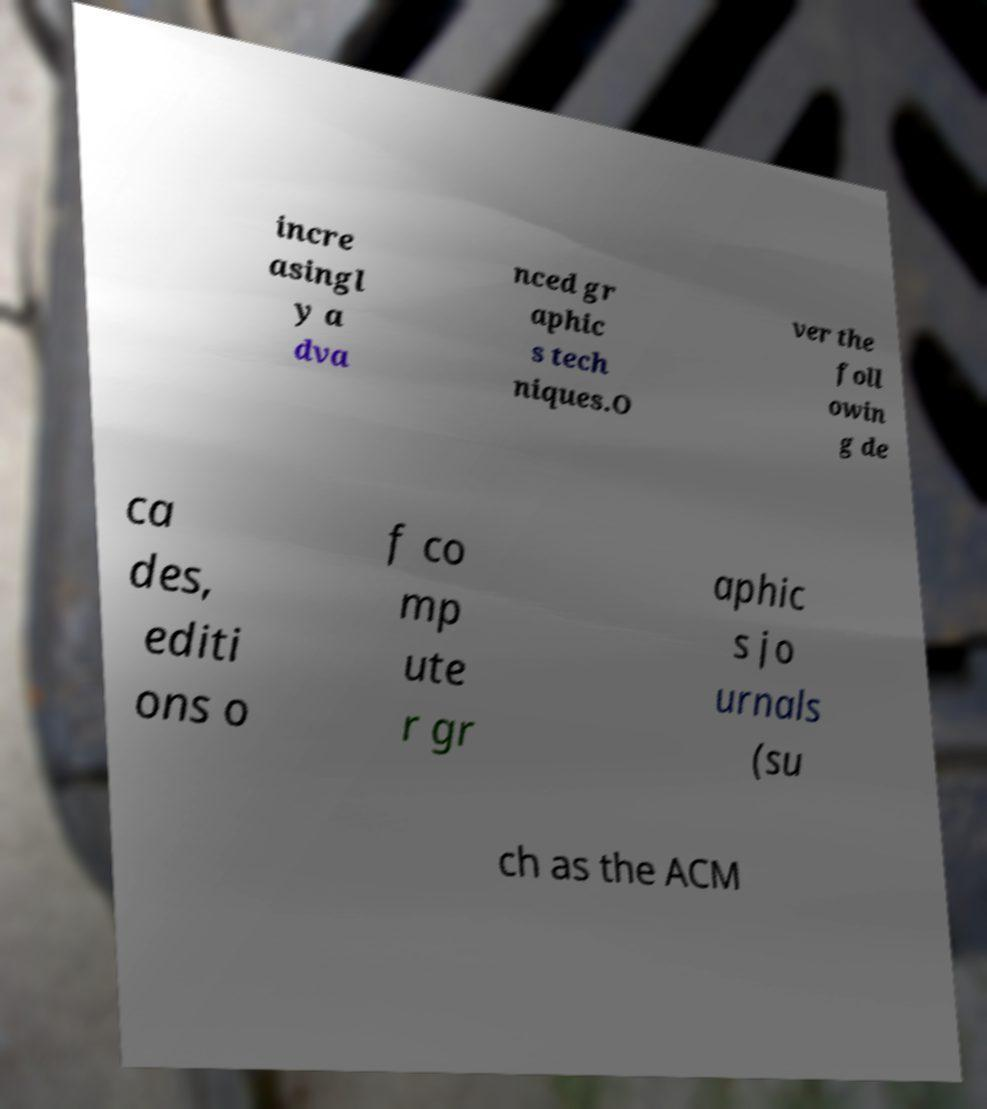Can you read and provide the text displayed in the image?This photo seems to have some interesting text. Can you extract and type it out for me? incre asingl y a dva nced gr aphic s tech niques.O ver the foll owin g de ca des, editi ons o f co mp ute r gr aphic s jo urnals (su ch as the ACM 